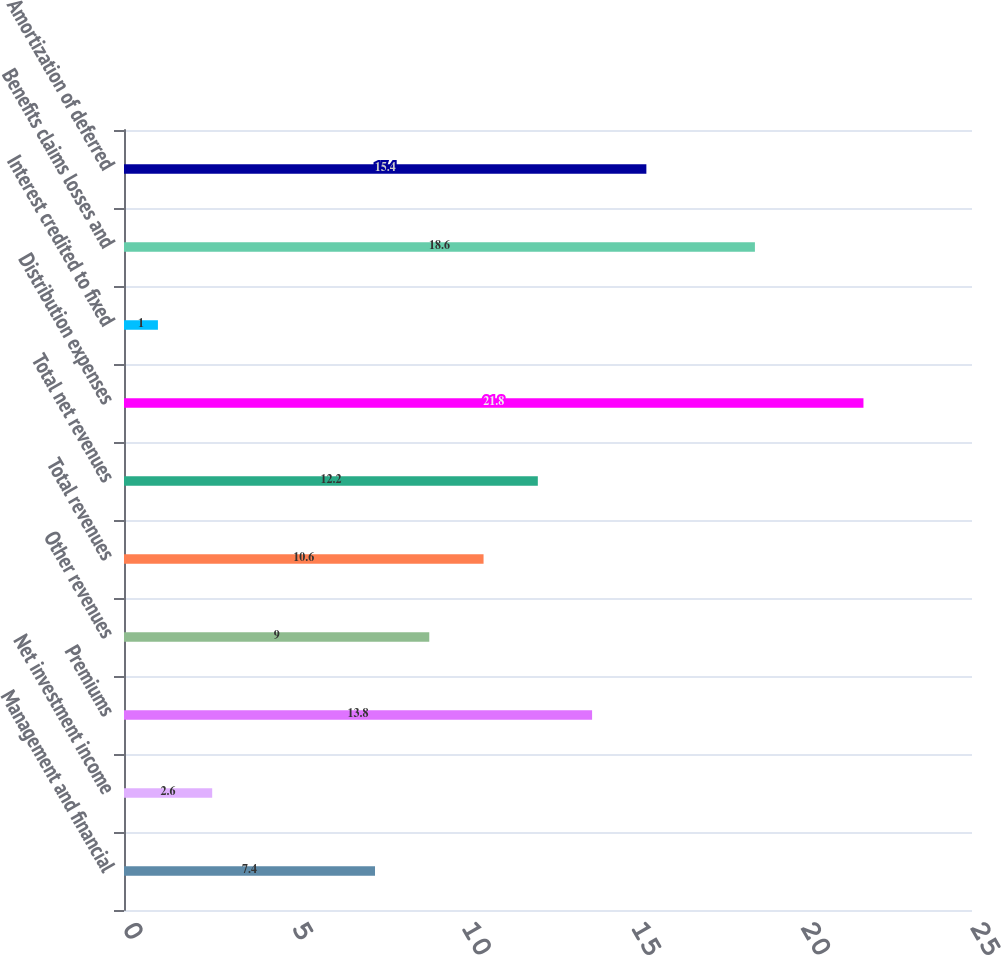Convert chart to OTSL. <chart><loc_0><loc_0><loc_500><loc_500><bar_chart><fcel>Management and financial<fcel>Net investment income<fcel>Premiums<fcel>Other revenues<fcel>Total revenues<fcel>Total net revenues<fcel>Distribution expenses<fcel>Interest credited to fixed<fcel>Benefits claims losses and<fcel>Amortization of deferred<nl><fcel>7.4<fcel>2.6<fcel>13.8<fcel>9<fcel>10.6<fcel>12.2<fcel>21.8<fcel>1<fcel>18.6<fcel>15.4<nl></chart> 